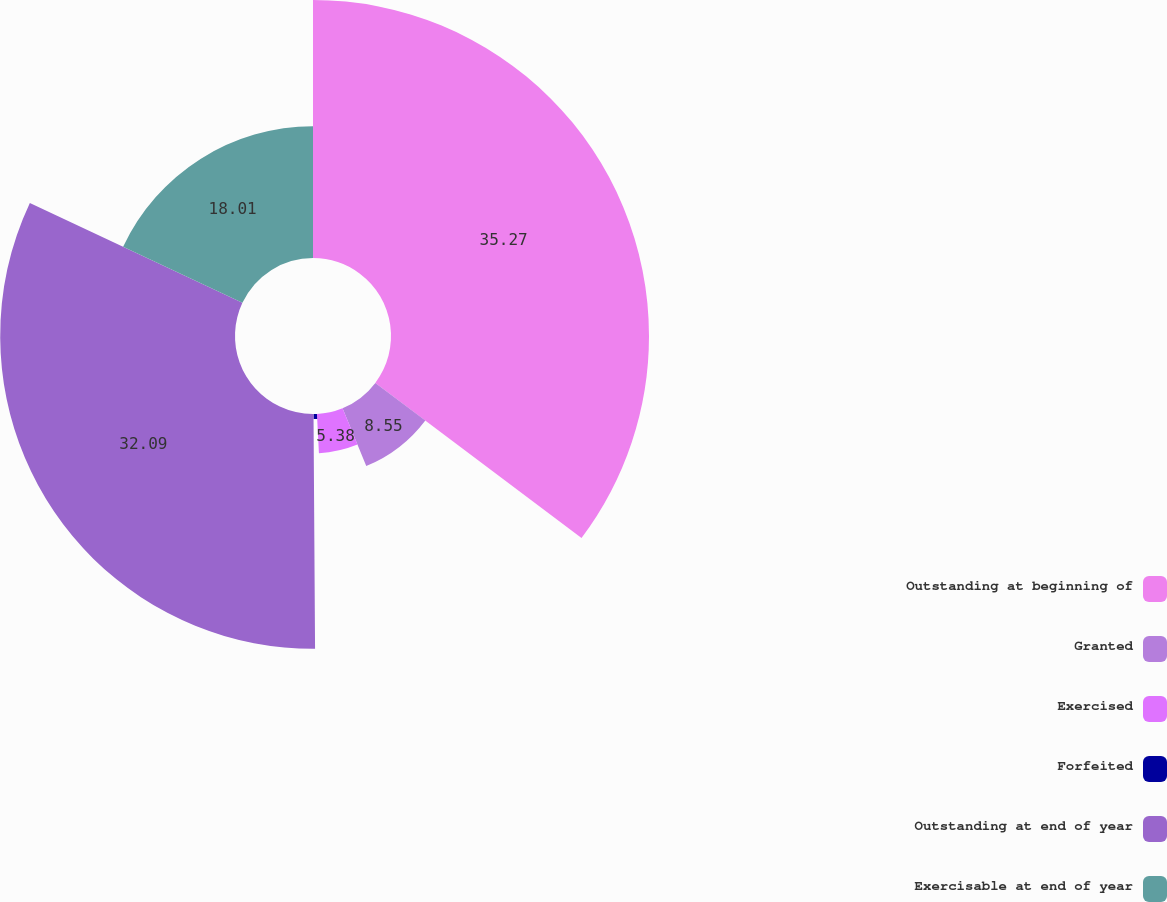<chart> <loc_0><loc_0><loc_500><loc_500><pie_chart><fcel>Outstanding at beginning of<fcel>Granted<fcel>Exercised<fcel>Forfeited<fcel>Outstanding at end of year<fcel>Exercisable at end of year<nl><fcel>35.26%<fcel>8.55%<fcel>5.38%<fcel>0.7%<fcel>32.09%<fcel>18.01%<nl></chart> 